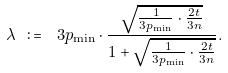<formula> <loc_0><loc_0><loc_500><loc_500>\lambda \ \colon = \ 3 p _ { \min } \cdot \frac { \sqrt { \frac { 1 } { 3 p _ { \min } } \cdot \frac { 2 t } { 3 n } } } { 1 + \sqrt { \frac { 1 } { 3 p _ { \min } } \cdot \frac { 2 t } { 3 n } } } .</formula> 